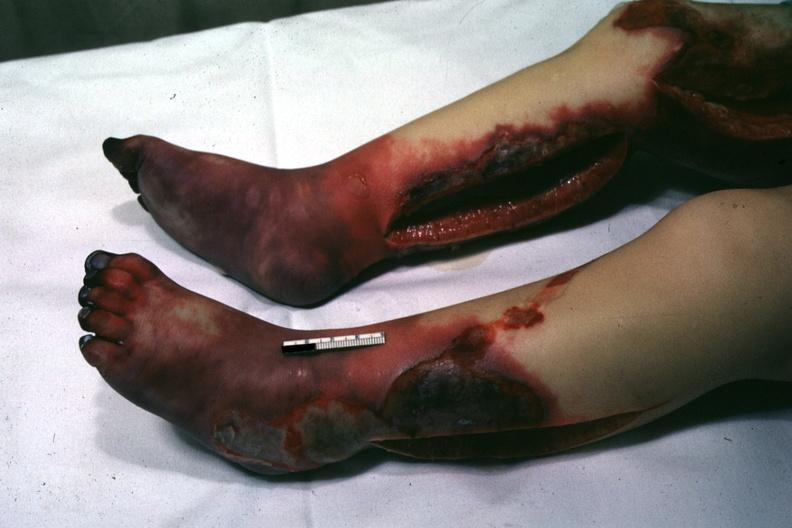s acrocyanosis present?
Answer the question using a single word or phrase. Yes 